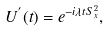Convert formula to latex. <formula><loc_0><loc_0><loc_500><loc_500>U ^ { ^ { \prime } } ( t ) = e ^ { - i \lambda t S _ { x } ^ { 2 } } ,</formula> 